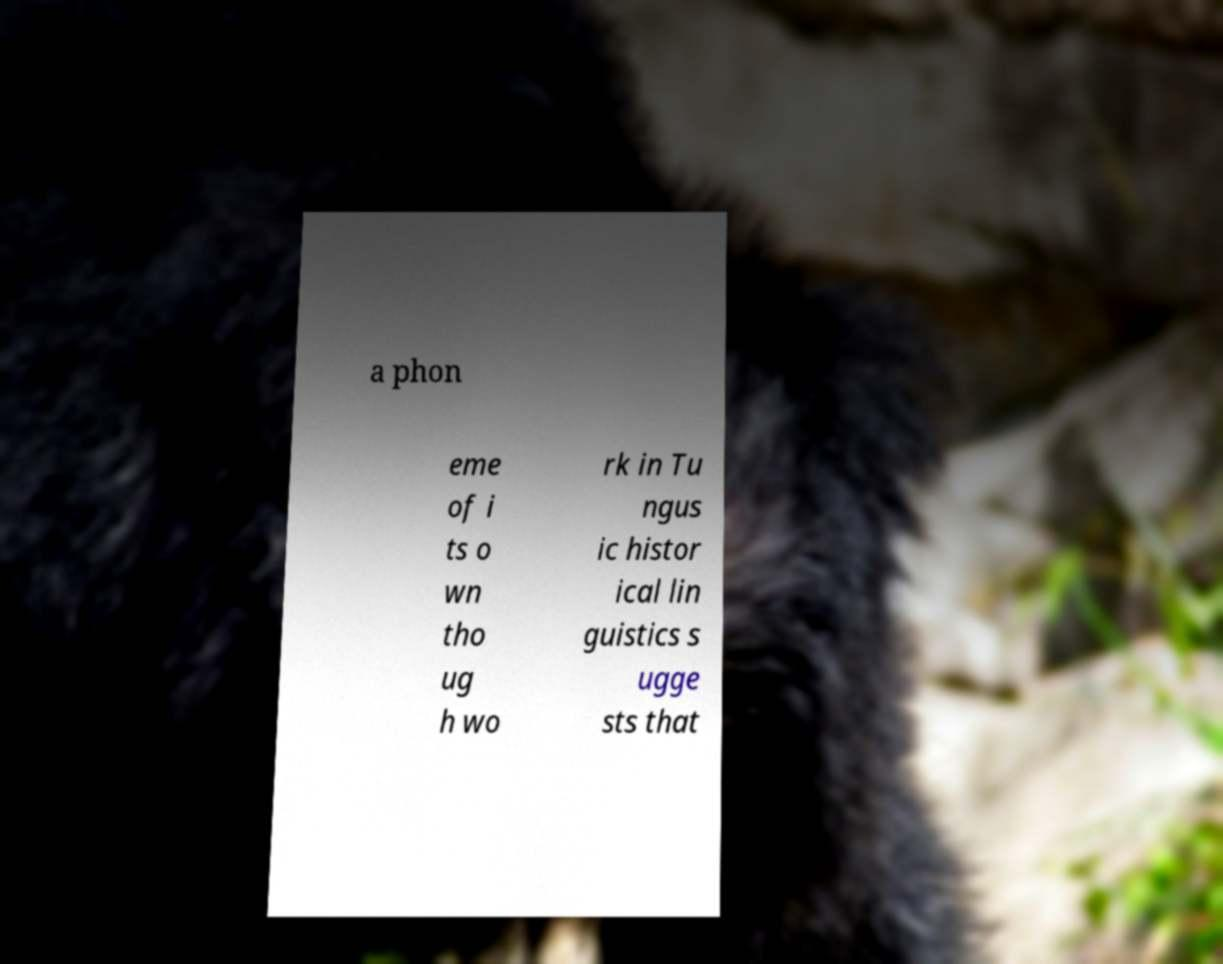For documentation purposes, I need the text within this image transcribed. Could you provide that? a phon eme of i ts o wn tho ug h wo rk in Tu ngus ic histor ical lin guistics s ugge sts that 